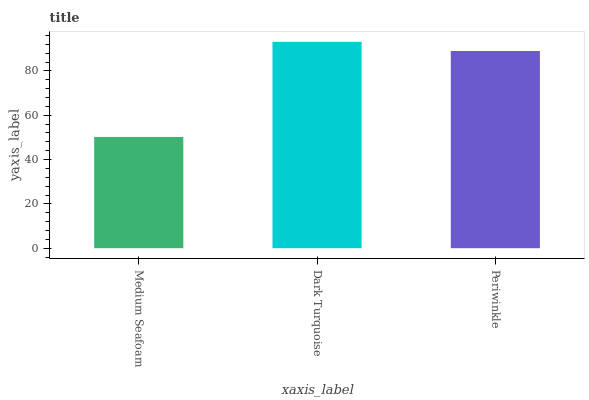Is Medium Seafoam the minimum?
Answer yes or no. Yes. Is Dark Turquoise the maximum?
Answer yes or no. Yes. Is Periwinkle the minimum?
Answer yes or no. No. Is Periwinkle the maximum?
Answer yes or no. No. Is Dark Turquoise greater than Periwinkle?
Answer yes or no. Yes. Is Periwinkle less than Dark Turquoise?
Answer yes or no. Yes. Is Periwinkle greater than Dark Turquoise?
Answer yes or no. No. Is Dark Turquoise less than Periwinkle?
Answer yes or no. No. Is Periwinkle the high median?
Answer yes or no. Yes. Is Periwinkle the low median?
Answer yes or no. Yes. Is Dark Turquoise the high median?
Answer yes or no. No. Is Dark Turquoise the low median?
Answer yes or no. No. 